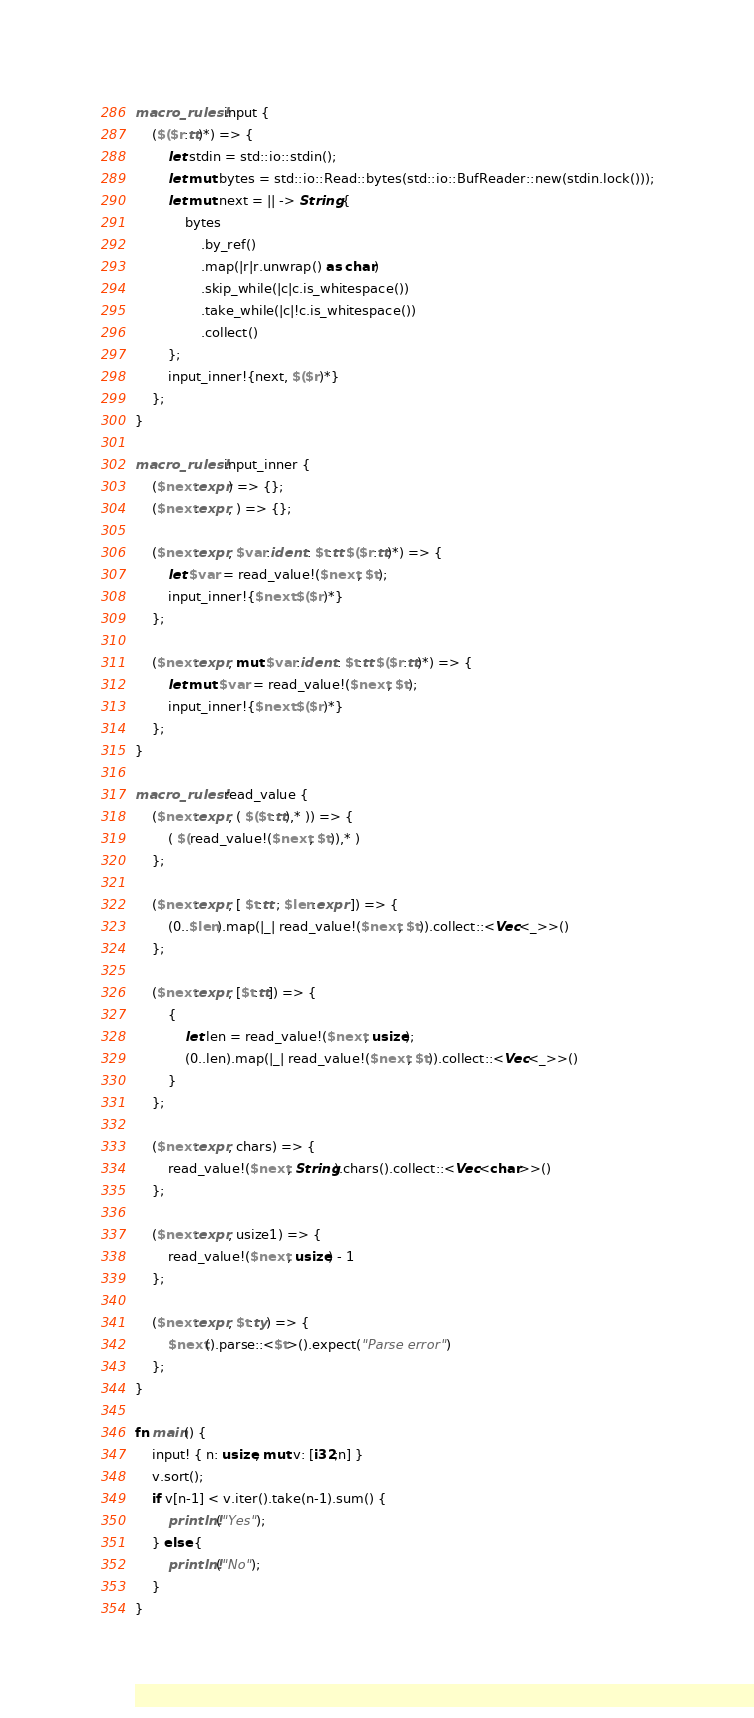Convert code to text. <code><loc_0><loc_0><loc_500><loc_500><_Rust_>macro_rules! input {
    ($($r:tt)*) => {
        let stdin = std::io::stdin();
        let mut bytes = std::io::Read::bytes(std::io::BufReader::new(stdin.lock()));
        let mut next = || -> String {
            bytes
                .by_ref()
                .map(|r|r.unwrap() as char)
                .skip_while(|c|c.is_whitespace())
                .take_while(|c|!c.is_whitespace())
                .collect()
        };
        input_inner!{next, $($r)*}
    };
}
 
macro_rules! input_inner {
    ($next:expr) => {};
    ($next:expr, ) => {};
 
    ($next:expr, $var:ident : $t:tt $($r:tt)*) => {
        let $var = read_value!($next, $t);
        input_inner!{$next $($r)*}
    };
    
    ($next:expr, mut $var:ident : $t:tt $($r:tt)*) => {
        let mut $var = read_value!($next, $t);
        input_inner!{$next $($r)*}
    };
}
 
macro_rules! read_value {
    ($next:expr, ( $($t:tt),* )) => {
        ( $(read_value!($next, $t)),* )
    };
 
    ($next:expr, [ $t:tt ; $len:expr ]) => {
        (0..$len).map(|_| read_value!($next, $t)).collect::<Vec<_>>()
    };

    ($next:expr, [$t:tt]) => {
        {
            let len = read_value!($next, usize);
            (0..len).map(|_| read_value!($next, $t)).collect::<Vec<_>>()
        }
    };
 
    ($next:expr, chars) => {
        read_value!($next, String).chars().collect::<Vec<char>>()
    };
 
    ($next:expr, usize1) => {
        read_value!($next, usize) - 1
    };
 
    ($next:expr, $t:ty) => {
        $next().parse::<$t>().expect("Parse error")
    };
}
 
fn main() {
    input! { n: usize, mut v: [i32;n] }
    v.sort(); 
    if v[n-1] < v.iter().take(n-1).sum() {
        println!("Yes");
    } else {
        println!("No");
    }
}</code> 